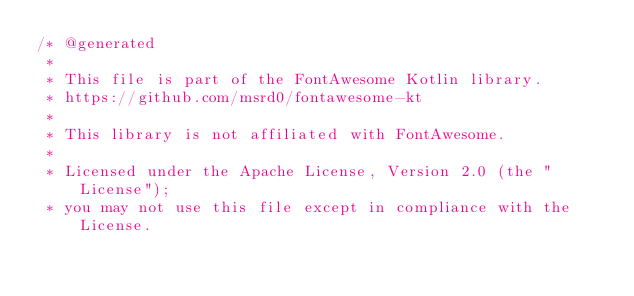<code> <loc_0><loc_0><loc_500><loc_500><_Kotlin_>/* @generated
 *
 * This file is part of the FontAwesome Kotlin library.
 * https://github.com/msrd0/fontawesome-kt
 *
 * This library is not affiliated with FontAwesome. 
 *
 * Licensed under the Apache License, Version 2.0 (the "License");
 * you may not use this file except in compliance with the License.</code> 